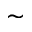Convert formula to latex. <formula><loc_0><loc_0><loc_500><loc_500>\sim</formula> 